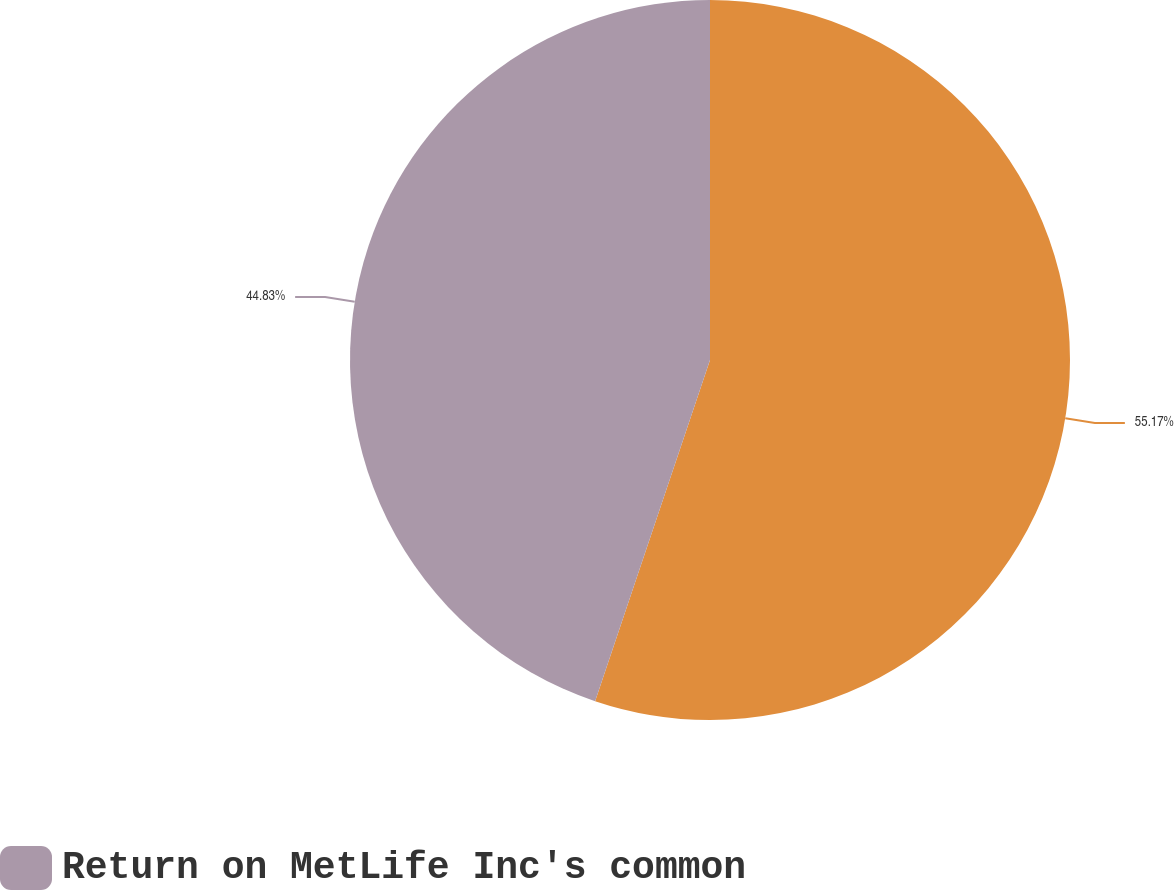<chart> <loc_0><loc_0><loc_500><loc_500><pie_chart><ecel><fcel>Return on MetLife Inc's common<nl><fcel>55.17%<fcel>44.83%<nl></chart> 